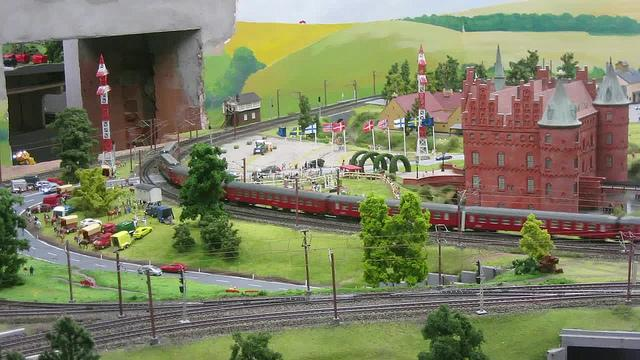Why does the background seem so flat and odd what type train scene does this signify that this is?

Choices:
A) current
B) new train
C) old
D) model train model train 